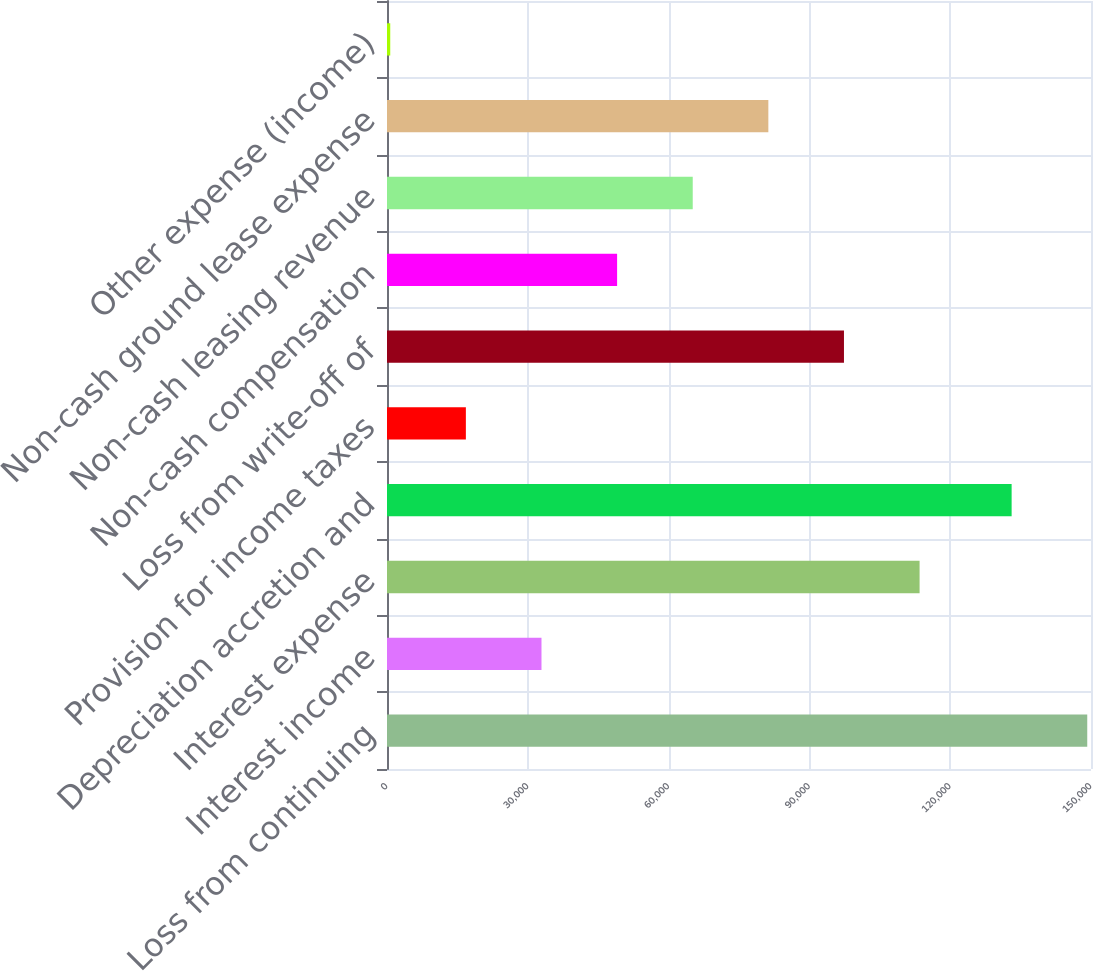Convert chart. <chart><loc_0><loc_0><loc_500><loc_500><bar_chart><fcel>Loss from continuing<fcel>Interest income<fcel>Interest expense<fcel>Depreciation accretion and<fcel>Provision for income taxes<fcel>Loss from write-off of<fcel>Non-cash compensation<fcel>Non-cash leasing revenue<fcel>Non-cash ground lease expense<fcel>Other expense (income)<nl><fcel>149200<fcel>32916.4<fcel>113477<fcel>133088<fcel>16804.2<fcel>97365.2<fcel>49028.6<fcel>65140.8<fcel>81253<fcel>692<nl></chart> 